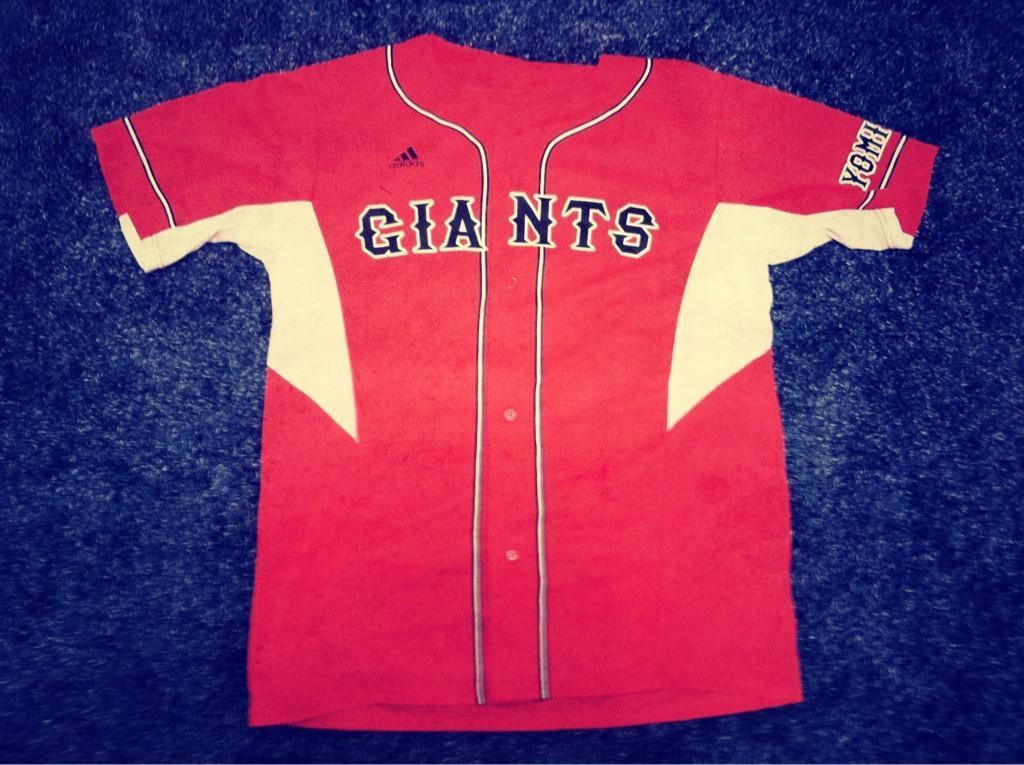Provide a one-sentence caption for the provided image. Red and yellow Giants jersey placed on a blue background. 